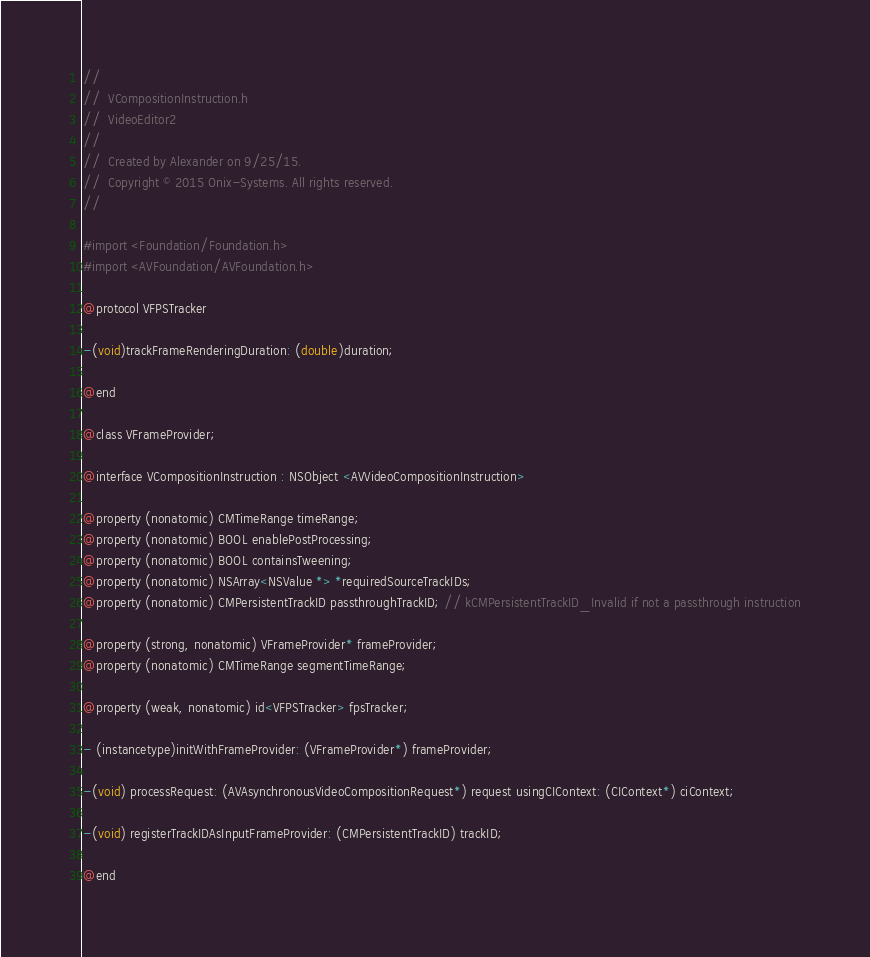<code> <loc_0><loc_0><loc_500><loc_500><_C_>//
//  VCompositionInstruction.h
//  VideoEditor2
//
//  Created by Alexander on 9/25/15.
//  Copyright © 2015 Onix-Systems. All rights reserved.
//

#import <Foundation/Foundation.h>
#import <AVFoundation/AVFoundation.h>

@protocol VFPSTracker

-(void)trackFrameRenderingDuration: (double)duration;

@end

@class VFrameProvider;

@interface VCompositionInstruction : NSObject <AVVideoCompositionInstruction>

@property (nonatomic) CMTimeRange timeRange;
@property (nonatomic) BOOL enablePostProcessing;
@property (nonatomic) BOOL containsTweening;
@property (nonatomic) NSArray<NSValue *> *requiredSourceTrackIDs;
@property (nonatomic) CMPersistentTrackID passthroughTrackID; // kCMPersistentTrackID_Invalid if not a passthrough instruction

@property (strong, nonatomic) VFrameProvider* frameProvider;
@property (nonatomic) CMTimeRange segmentTimeRange;

@property (weak, nonatomic) id<VFPSTracker> fpsTracker;

- (instancetype)initWithFrameProvider: (VFrameProvider*) frameProvider;

-(void) processRequest: (AVAsynchronousVideoCompositionRequest*) request usingCIContext: (CIContext*) ciContext;

-(void) registerTrackIDAsInputFrameProvider: (CMPersistentTrackID) trackID;

@end
</code> 